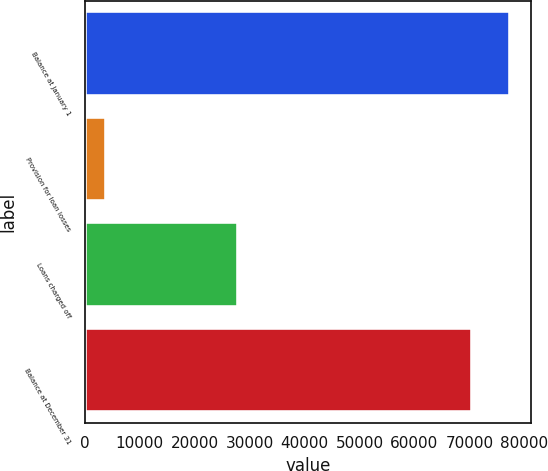<chart> <loc_0><loc_0><loc_500><loc_500><bar_chart><fcel>Balance at January 1<fcel>Provision for loan losses<fcel>Loans charged off<fcel>Balance at December 31<nl><fcel>77349.3<fcel>3882<fcel>27932<fcel>70500<nl></chart> 